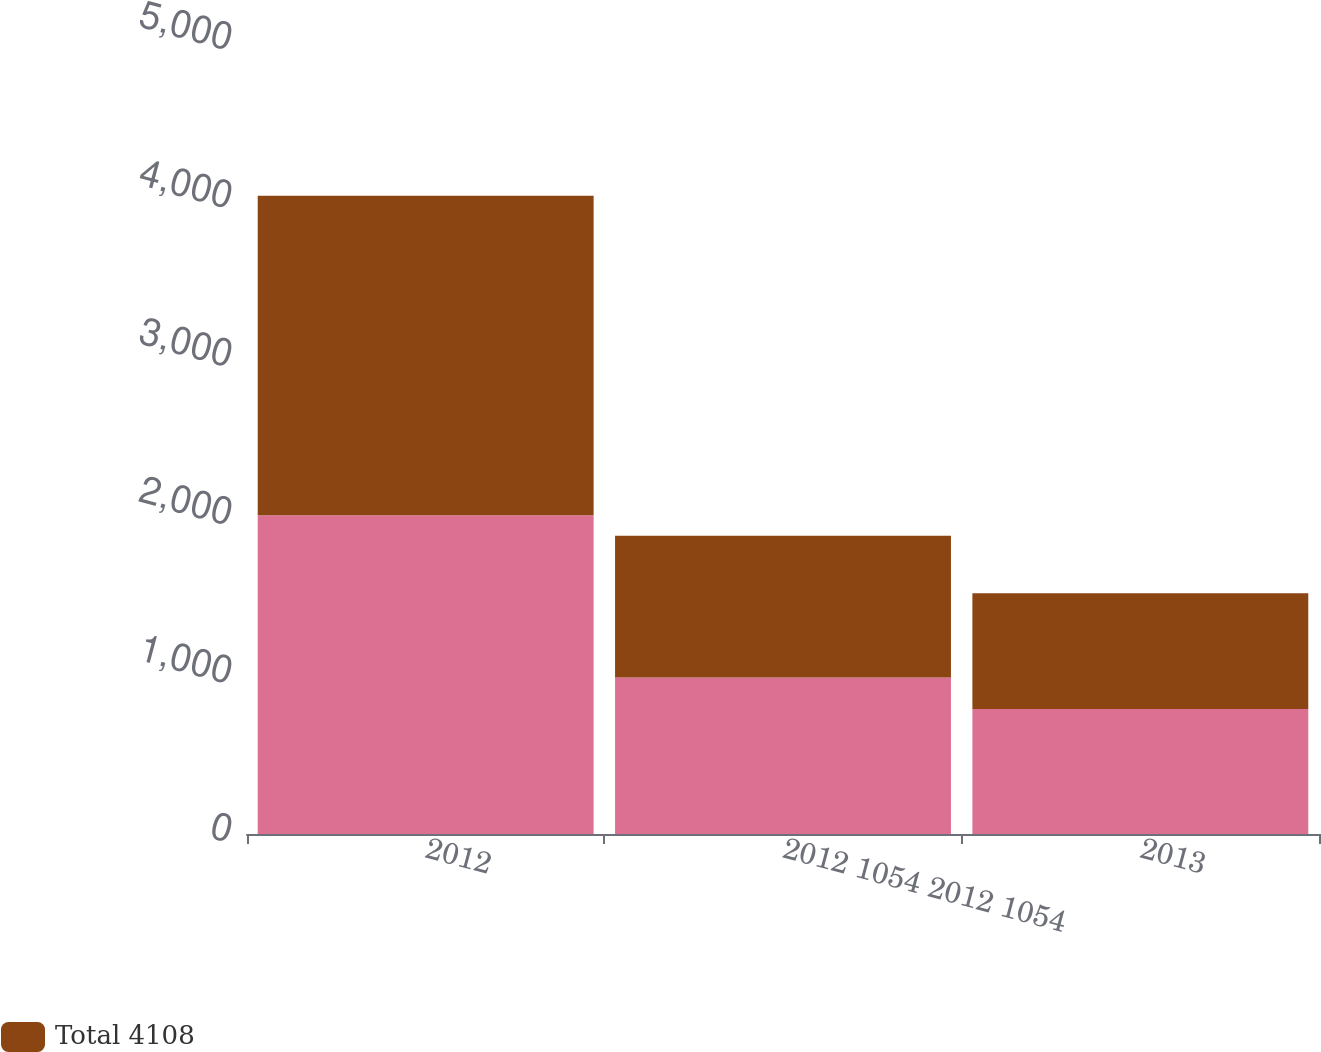Convert chart to OTSL. <chart><loc_0><loc_0><loc_500><loc_500><stacked_bar_chart><ecel><fcel>2012<fcel>2012 1054 2012 1054<fcel>2013<nl><fcel>nan<fcel>2013<fcel>988<fcel>789<nl><fcel>Total 4108<fcel>2016<fcel>895<fcel>731<nl></chart> 